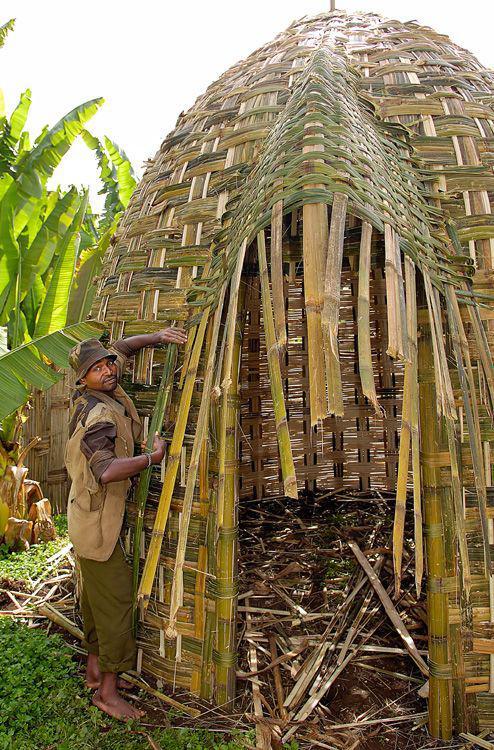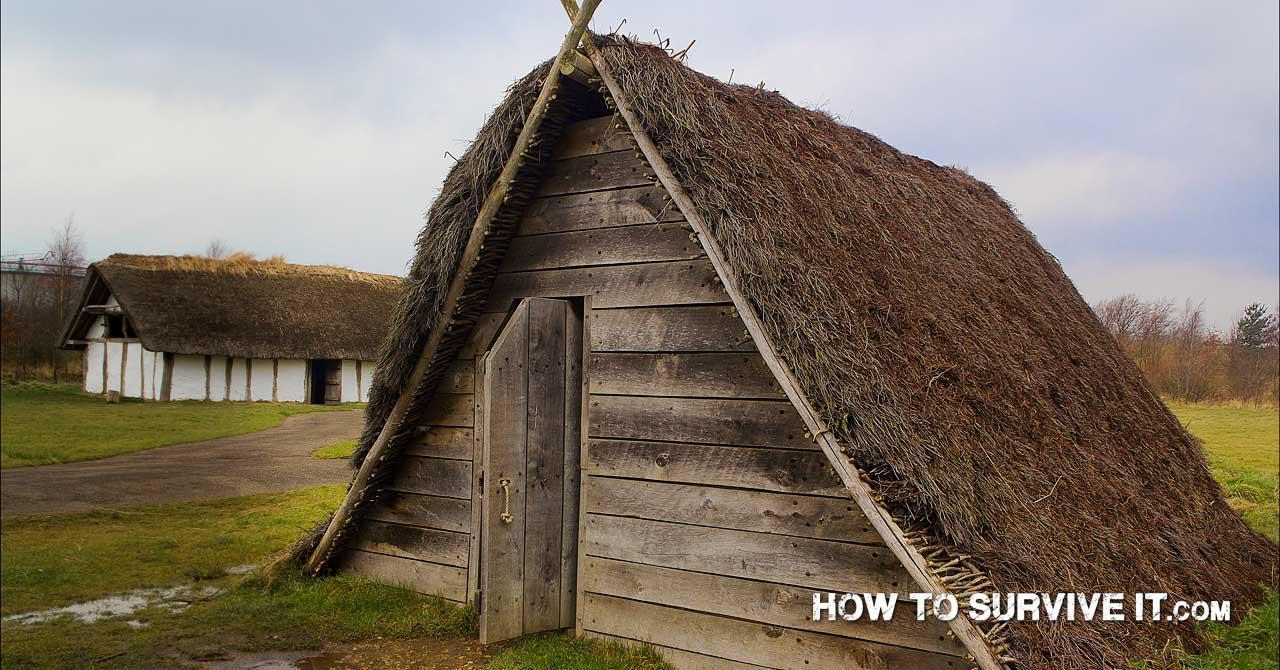The first image is the image on the left, the second image is the image on the right. Analyze the images presented: Is the assertion "None of the shelters have a door." valid? Answer yes or no. No. 